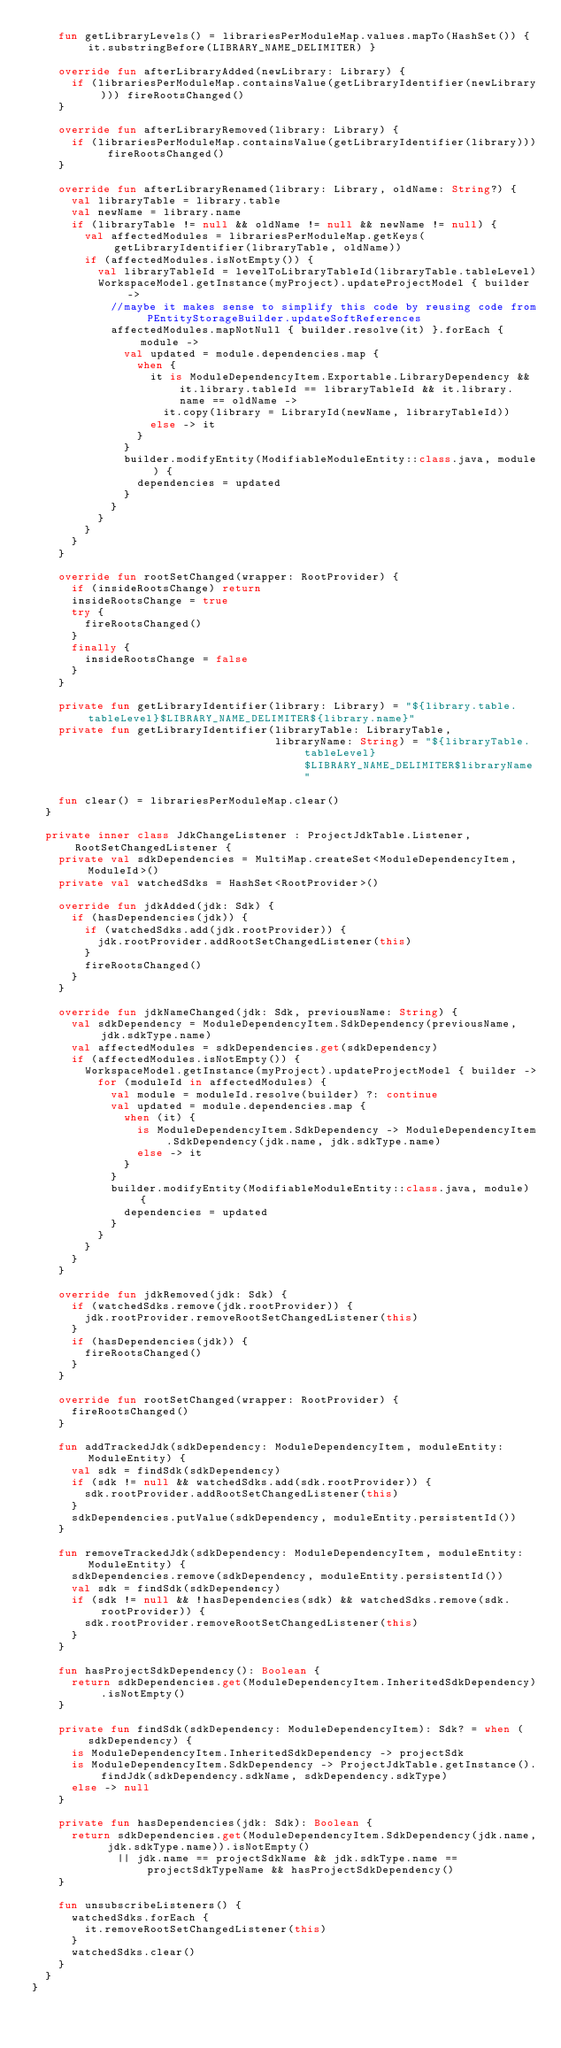<code> <loc_0><loc_0><loc_500><loc_500><_Kotlin_>    fun getLibraryLevels() = librariesPerModuleMap.values.mapTo(HashSet()) { it.substringBefore(LIBRARY_NAME_DELIMITER) }

    override fun afterLibraryAdded(newLibrary: Library) {
      if (librariesPerModuleMap.containsValue(getLibraryIdentifier(newLibrary))) fireRootsChanged()
    }

    override fun afterLibraryRemoved(library: Library) {
      if (librariesPerModuleMap.containsValue(getLibraryIdentifier(library))) fireRootsChanged()
    }

    override fun afterLibraryRenamed(library: Library, oldName: String?) {
      val libraryTable = library.table
      val newName = library.name
      if (libraryTable != null && oldName != null && newName != null) {
        val affectedModules = librariesPerModuleMap.getKeys(getLibraryIdentifier(libraryTable, oldName))
        if (affectedModules.isNotEmpty()) {
          val libraryTableId = levelToLibraryTableId(libraryTable.tableLevel)
          WorkspaceModel.getInstance(myProject).updateProjectModel { builder ->
            //maybe it makes sense to simplify this code by reusing code from PEntityStorageBuilder.updateSoftReferences
            affectedModules.mapNotNull { builder.resolve(it) }.forEach { module ->
              val updated = module.dependencies.map {
                when {
                  it is ModuleDependencyItem.Exportable.LibraryDependency && it.library.tableId == libraryTableId && it.library.name == oldName ->
                    it.copy(library = LibraryId(newName, libraryTableId))
                  else -> it
                }
              }
              builder.modifyEntity(ModifiableModuleEntity::class.java, module) {
                dependencies = updated
              }
            }
          }
        }
      }
    }

    override fun rootSetChanged(wrapper: RootProvider) {
      if (insideRootsChange) return
      insideRootsChange = true
      try {
        fireRootsChanged()
      }
      finally {
        insideRootsChange = false
      }
    }

    private fun getLibraryIdentifier(library: Library) = "${library.table.tableLevel}$LIBRARY_NAME_DELIMITER${library.name}"
    private fun getLibraryIdentifier(libraryTable: LibraryTable,
                                     libraryName: String) = "${libraryTable.tableLevel}$LIBRARY_NAME_DELIMITER$libraryName"

    fun clear() = librariesPerModuleMap.clear()
  }

  private inner class JdkChangeListener : ProjectJdkTable.Listener, RootSetChangedListener {
    private val sdkDependencies = MultiMap.createSet<ModuleDependencyItem, ModuleId>()
    private val watchedSdks = HashSet<RootProvider>()

    override fun jdkAdded(jdk: Sdk) {
      if (hasDependencies(jdk)) {
        if (watchedSdks.add(jdk.rootProvider)) {
          jdk.rootProvider.addRootSetChangedListener(this)
        }
        fireRootsChanged()
      }
    }

    override fun jdkNameChanged(jdk: Sdk, previousName: String) {
      val sdkDependency = ModuleDependencyItem.SdkDependency(previousName, jdk.sdkType.name)
      val affectedModules = sdkDependencies.get(sdkDependency)
      if (affectedModules.isNotEmpty()) {
        WorkspaceModel.getInstance(myProject).updateProjectModel { builder ->
          for (moduleId in affectedModules) {
            val module = moduleId.resolve(builder) ?: continue
            val updated = module.dependencies.map {
              when (it) {
                is ModuleDependencyItem.SdkDependency -> ModuleDependencyItem.SdkDependency(jdk.name, jdk.sdkType.name)
                else -> it
              }
            }
            builder.modifyEntity(ModifiableModuleEntity::class.java, module) {
              dependencies = updated
            }
          }
        }
      }
    }

    override fun jdkRemoved(jdk: Sdk) {
      if (watchedSdks.remove(jdk.rootProvider)) {
        jdk.rootProvider.removeRootSetChangedListener(this)
      }
      if (hasDependencies(jdk)) {
        fireRootsChanged()
      }
    }

    override fun rootSetChanged(wrapper: RootProvider) {
      fireRootsChanged()
    }

    fun addTrackedJdk(sdkDependency: ModuleDependencyItem, moduleEntity: ModuleEntity) {
      val sdk = findSdk(sdkDependency)
      if (sdk != null && watchedSdks.add(sdk.rootProvider)) {
        sdk.rootProvider.addRootSetChangedListener(this)
      }
      sdkDependencies.putValue(sdkDependency, moduleEntity.persistentId())
    }

    fun removeTrackedJdk(sdkDependency: ModuleDependencyItem, moduleEntity: ModuleEntity) {
      sdkDependencies.remove(sdkDependency, moduleEntity.persistentId())
      val sdk = findSdk(sdkDependency)
      if (sdk != null && !hasDependencies(sdk) && watchedSdks.remove(sdk.rootProvider)) {
        sdk.rootProvider.removeRootSetChangedListener(this)
      }
    }

    fun hasProjectSdkDependency(): Boolean {
      return sdkDependencies.get(ModuleDependencyItem.InheritedSdkDependency).isNotEmpty()
    }

    private fun findSdk(sdkDependency: ModuleDependencyItem): Sdk? = when (sdkDependency) {
      is ModuleDependencyItem.InheritedSdkDependency -> projectSdk
      is ModuleDependencyItem.SdkDependency -> ProjectJdkTable.getInstance().findJdk(sdkDependency.sdkName, sdkDependency.sdkType)
      else -> null
    }

    private fun hasDependencies(jdk: Sdk): Boolean {
      return sdkDependencies.get(ModuleDependencyItem.SdkDependency(jdk.name, jdk.sdkType.name)).isNotEmpty()
             || jdk.name == projectSdkName && jdk.sdkType.name == projectSdkTypeName && hasProjectSdkDependency()
    }

    fun unsubscribeListeners() {
      watchedSdks.forEach {
        it.removeRootSetChangedListener(this)
      }
      watchedSdks.clear()
    }
  }
}</code> 